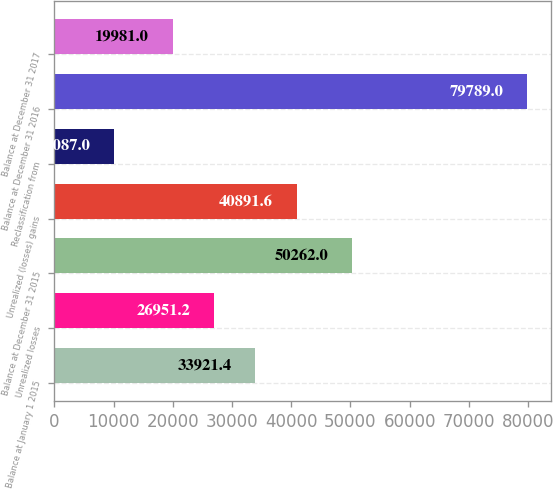<chart> <loc_0><loc_0><loc_500><loc_500><bar_chart><fcel>Balance at January 1 2015<fcel>Unrealized losses<fcel>Balance at December 31 2015<fcel>Unrealized (losses) gains<fcel>Reclassification from<fcel>Balance at December 31 2016<fcel>Balance at December 31 2017<nl><fcel>33921.4<fcel>26951.2<fcel>50262<fcel>40891.6<fcel>10087<fcel>79789<fcel>19981<nl></chart> 